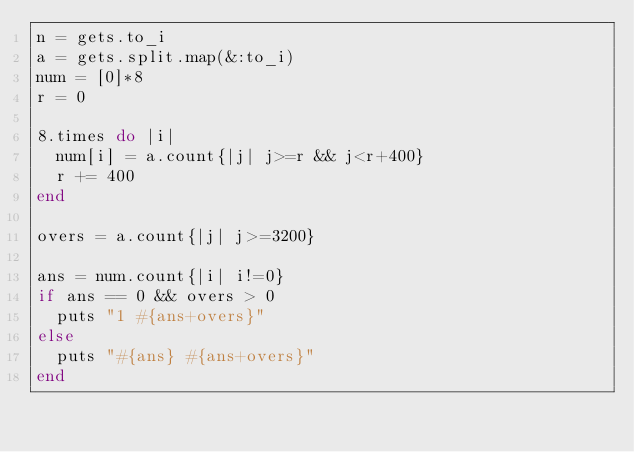<code> <loc_0><loc_0><loc_500><loc_500><_Ruby_>n = gets.to_i
a = gets.split.map(&:to_i)
num = [0]*8
r = 0

8.times do |i|
  num[i] = a.count{|j| j>=r && j<r+400}
  r += 400
end

overs = a.count{|j| j>=3200}

ans = num.count{|i| i!=0}
if ans == 0 && overs > 0
  puts "1 #{ans+overs}"
else
  puts "#{ans} #{ans+overs}"
end
</code> 